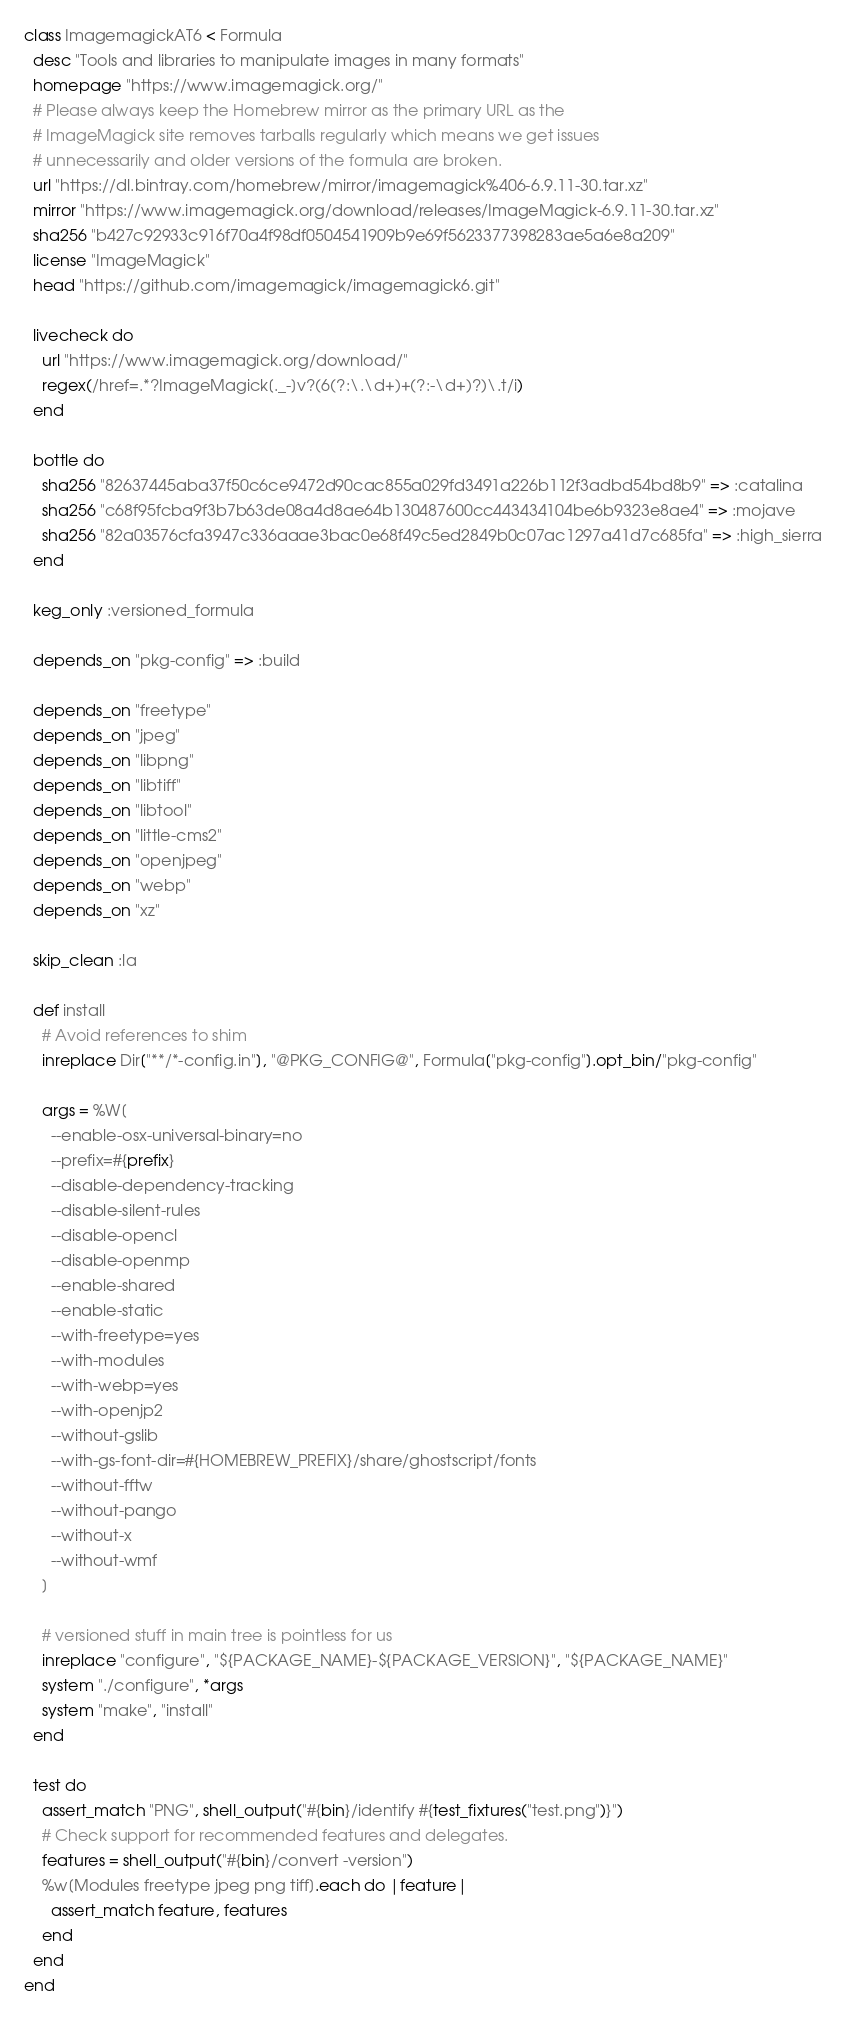<code> <loc_0><loc_0><loc_500><loc_500><_Ruby_>class ImagemagickAT6 < Formula
  desc "Tools and libraries to manipulate images in many formats"
  homepage "https://www.imagemagick.org/"
  # Please always keep the Homebrew mirror as the primary URL as the
  # ImageMagick site removes tarballs regularly which means we get issues
  # unnecessarily and older versions of the formula are broken.
  url "https://dl.bintray.com/homebrew/mirror/imagemagick%406-6.9.11-30.tar.xz"
  mirror "https://www.imagemagick.org/download/releases/ImageMagick-6.9.11-30.tar.xz"
  sha256 "b427c92933c916f70a4f98df0504541909b9e69f5623377398283ae5a6e8a209"
  license "ImageMagick"
  head "https://github.com/imagemagick/imagemagick6.git"

  livecheck do
    url "https://www.imagemagick.org/download/"
    regex(/href=.*?ImageMagick[._-]v?(6(?:\.\d+)+(?:-\d+)?)\.t/i)
  end

  bottle do
    sha256 "82637445aba37f50c6ce9472d90cac855a029fd3491a226b112f3adbd54bd8b9" => :catalina
    sha256 "c68f95fcba9f3b7b63de08a4d8ae64b130487600cc443434104be6b9323e8ae4" => :mojave
    sha256 "82a03576cfa3947c336aaae3bac0e68f49c5ed2849b0c07ac1297a41d7c685fa" => :high_sierra
  end

  keg_only :versioned_formula

  depends_on "pkg-config" => :build

  depends_on "freetype"
  depends_on "jpeg"
  depends_on "libpng"
  depends_on "libtiff"
  depends_on "libtool"
  depends_on "little-cms2"
  depends_on "openjpeg"
  depends_on "webp"
  depends_on "xz"

  skip_clean :la

  def install
    # Avoid references to shim
    inreplace Dir["**/*-config.in"], "@PKG_CONFIG@", Formula["pkg-config"].opt_bin/"pkg-config"

    args = %W[
      --enable-osx-universal-binary=no
      --prefix=#{prefix}
      --disable-dependency-tracking
      --disable-silent-rules
      --disable-opencl
      --disable-openmp
      --enable-shared
      --enable-static
      --with-freetype=yes
      --with-modules
      --with-webp=yes
      --with-openjp2
      --without-gslib
      --with-gs-font-dir=#{HOMEBREW_PREFIX}/share/ghostscript/fonts
      --without-fftw
      --without-pango
      --without-x
      --without-wmf
    ]

    # versioned stuff in main tree is pointless for us
    inreplace "configure", "${PACKAGE_NAME}-${PACKAGE_VERSION}", "${PACKAGE_NAME}"
    system "./configure", *args
    system "make", "install"
  end

  test do
    assert_match "PNG", shell_output("#{bin}/identify #{test_fixtures("test.png")}")
    # Check support for recommended features and delegates.
    features = shell_output("#{bin}/convert -version")
    %w[Modules freetype jpeg png tiff].each do |feature|
      assert_match feature, features
    end
  end
end
</code> 